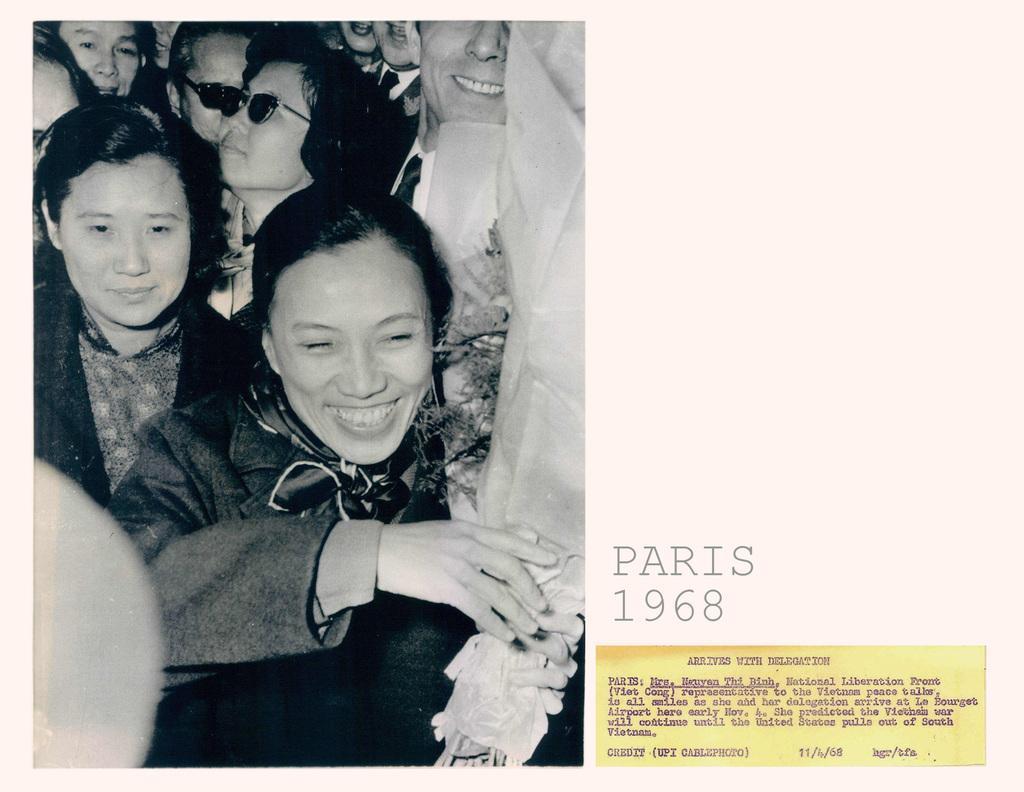Could you give a brief overview of what you see in this image? In this image on the left side there are some people who are standing and some of them are smiling, on the right side there is some text. 